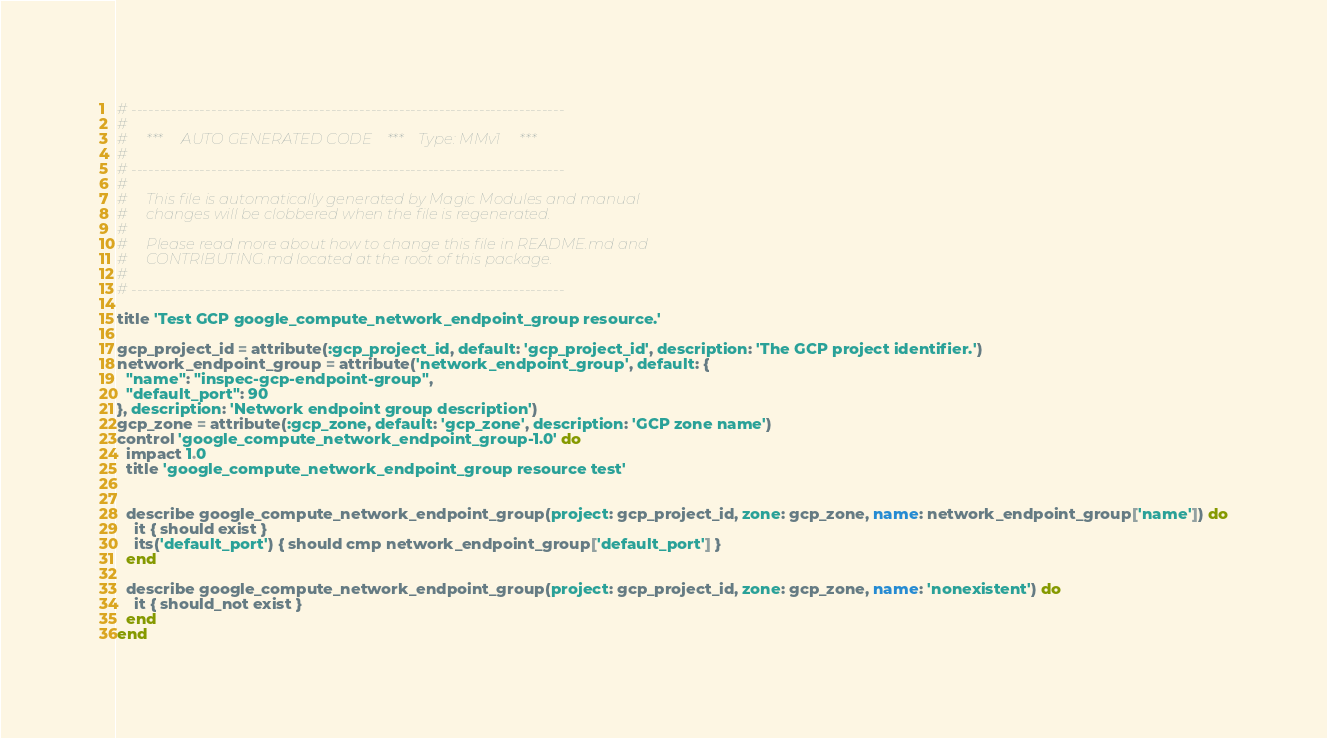Convert code to text. <code><loc_0><loc_0><loc_500><loc_500><_Ruby_># ----------------------------------------------------------------------------
#
#     ***     AUTO GENERATED CODE    ***    Type: MMv1     ***
#
# ----------------------------------------------------------------------------
#
#     This file is automatically generated by Magic Modules and manual
#     changes will be clobbered when the file is regenerated.
#
#     Please read more about how to change this file in README.md and
#     CONTRIBUTING.md located at the root of this package.
#
# ----------------------------------------------------------------------------

title 'Test GCP google_compute_network_endpoint_group resource.'

gcp_project_id = attribute(:gcp_project_id, default: 'gcp_project_id', description: 'The GCP project identifier.')
network_endpoint_group = attribute('network_endpoint_group', default: {
  "name": "inspec-gcp-endpoint-group",
  "default_port": 90
}, description: 'Network endpoint group description')
gcp_zone = attribute(:gcp_zone, default: 'gcp_zone', description: 'GCP zone name')
control 'google_compute_network_endpoint_group-1.0' do
  impact 1.0
  title 'google_compute_network_endpoint_group resource test'


  describe google_compute_network_endpoint_group(project: gcp_project_id, zone: gcp_zone, name: network_endpoint_group['name']) do
    it { should exist }
    its('default_port') { should cmp network_endpoint_group['default_port'] }
  end

  describe google_compute_network_endpoint_group(project: gcp_project_id, zone: gcp_zone, name: 'nonexistent') do
    it { should_not exist }
  end
end
</code> 